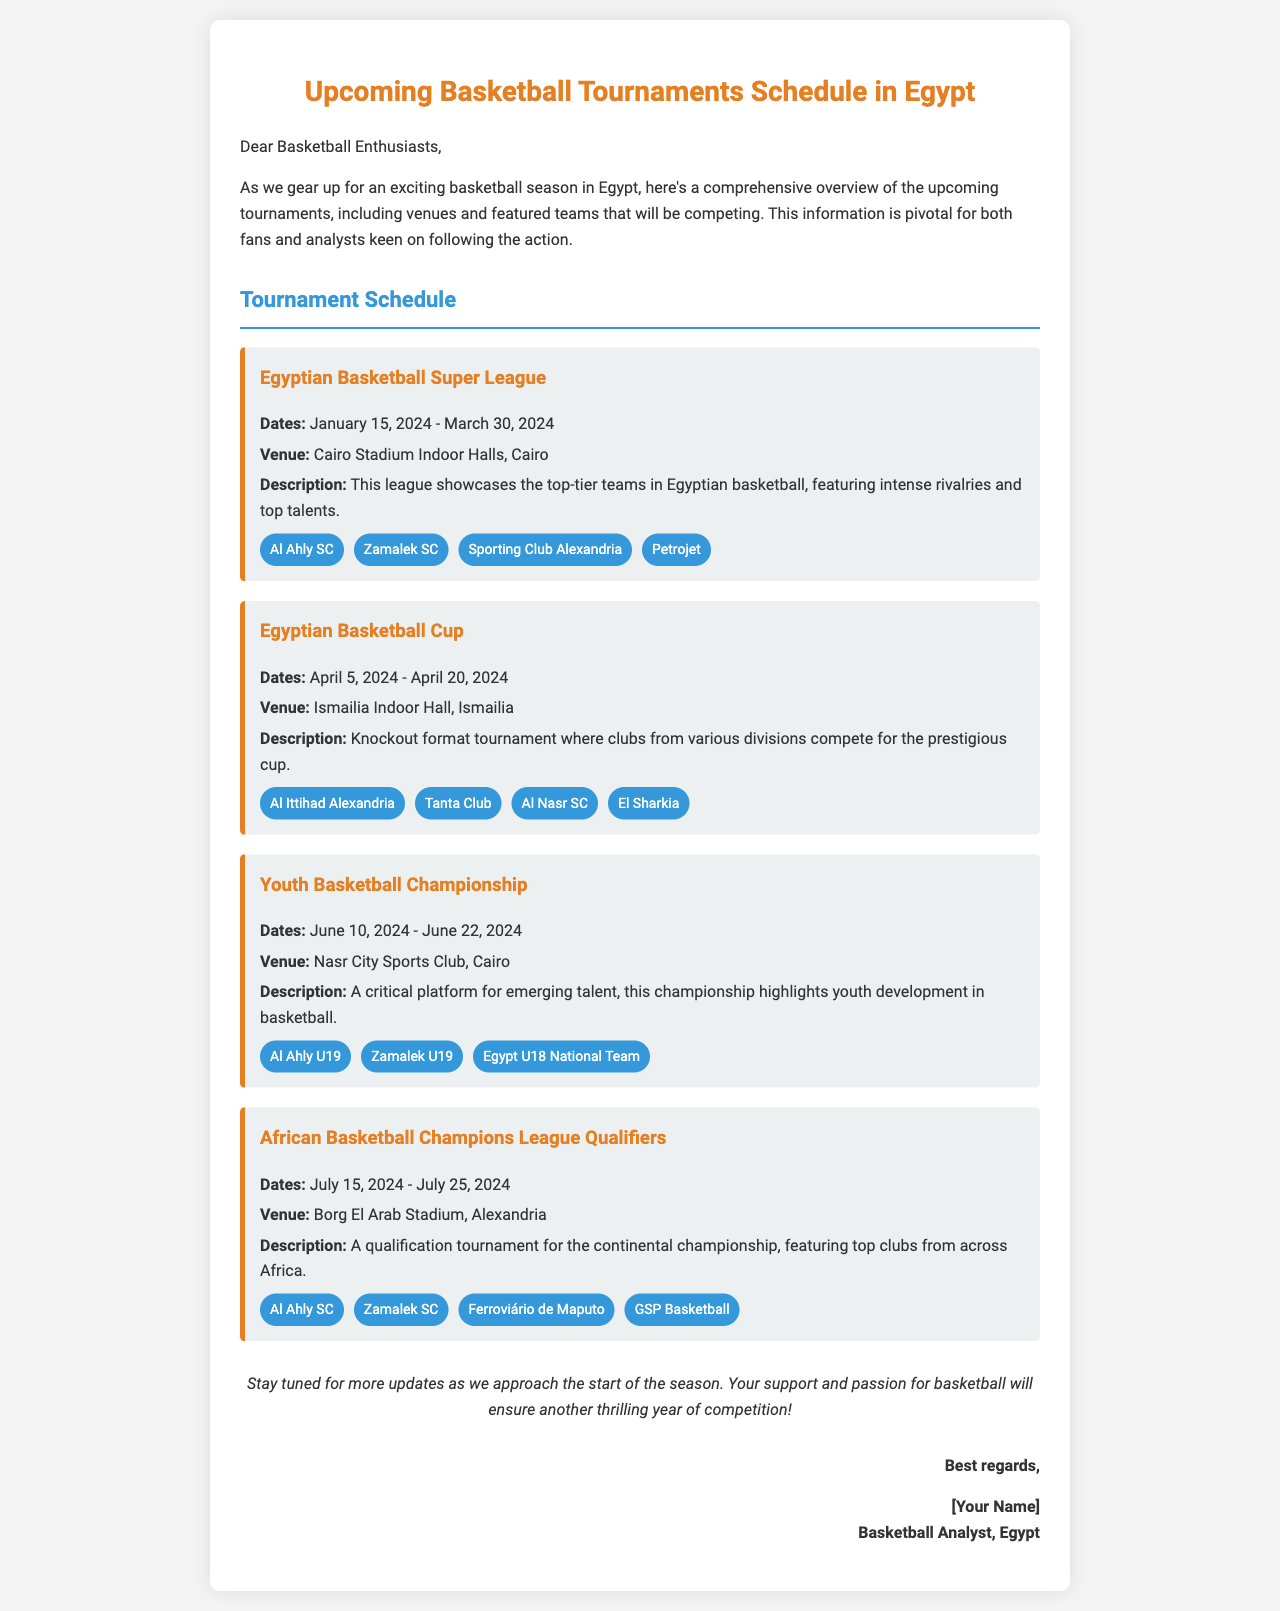What are the dates for the Egyptian Basketball Super League? The document states the dates for the Egyptian Basketball Super League as January 15, 2024 - March 30, 2024.
Answer: January 15, 2024 - March 30, 2024 Where will the Egyptian Basketball Cup take place? According to the document, the venue for the Egyptian Basketball Cup is Ismailia Indoor Hall, Ismailia.
Answer: Ismailia Indoor Hall, Ismailia Which teams are featured in the Youth Basketball Championship? The document lists the featured teams in the Youth Basketball Championship as Al Ahly U19, Zamalek U19, and Egypt U18 National Team.
Answer: Al Ahly U19, Zamalek U19, Egypt U18 National Team What is the primary focus of the Youth Basketball Championship? The document describes the focus of the Youth Basketball Championship as highlighting youth development in basketball.
Answer: Youth development in basketball What will the African Basketball Champions League Qualifiers determine? The document states that the African Basketball Champions League Qualifiers is a qualification tournament for the continental championship.
Answer: Qualification for the continental championship 